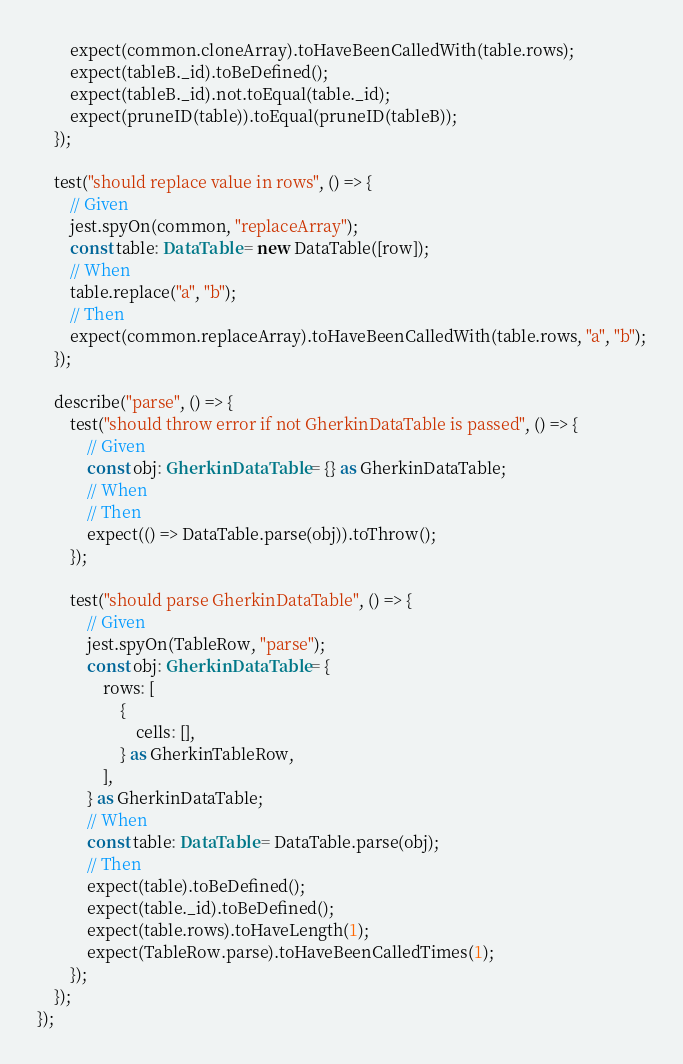<code> <loc_0><loc_0><loc_500><loc_500><_TypeScript_>        expect(common.cloneArray).toHaveBeenCalledWith(table.rows);
        expect(tableB._id).toBeDefined();
        expect(tableB._id).not.toEqual(table._id);
        expect(pruneID(table)).toEqual(pruneID(tableB));
    });

    test("should replace value in rows", () => {
        // Given
        jest.spyOn(common, "replaceArray");
        const table: DataTable = new DataTable([row]);
        // When
        table.replace("a", "b");
        // Then
        expect(common.replaceArray).toHaveBeenCalledWith(table.rows, "a", "b");
    });

    describe("parse", () => {
        test("should throw error if not GherkinDataTable is passed", () => {
            // Given
            const obj: GherkinDataTable = {} as GherkinDataTable;
            // When
            // Then
            expect(() => DataTable.parse(obj)).toThrow();
        });

        test("should parse GherkinDataTable", () => {
            // Given
            jest.spyOn(TableRow, "parse");
            const obj: GherkinDataTable = {
                rows: [
                    {
                        cells: [],
                    } as GherkinTableRow,
                ],
            } as GherkinDataTable;
            // When
            const table: DataTable = DataTable.parse(obj);
            // Then
            expect(table).toBeDefined();
            expect(table._id).toBeDefined();
            expect(table.rows).toHaveLength(1);
            expect(TableRow.parse).toHaveBeenCalledTimes(1);
        });
    });
});
</code> 